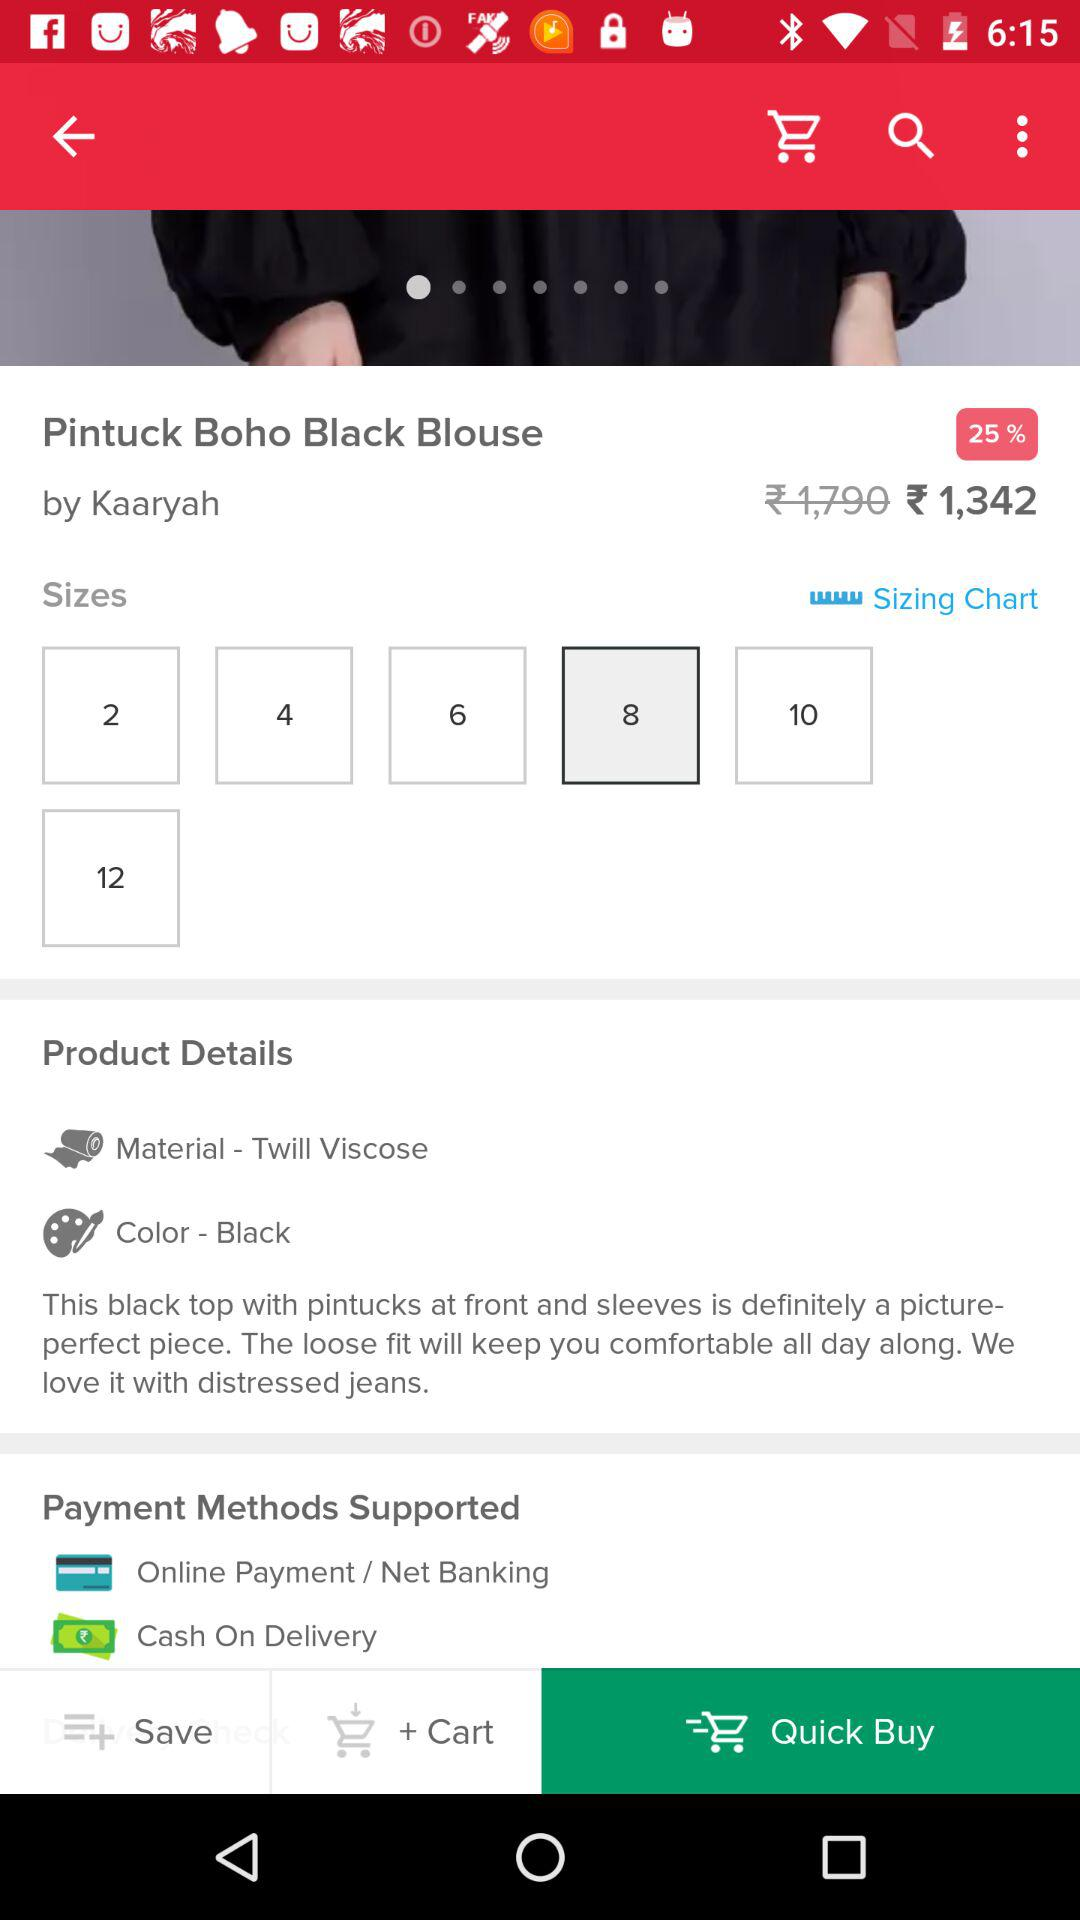What is the color of the blouse? The color of the blouse is black. 